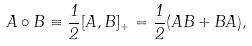<formula> <loc_0><loc_0><loc_500><loc_500>A \circ B \equiv \frac { 1 } { 2 } [ A , B ] _ { + } = \frac { 1 } { 2 } ( A B + B A ) ,</formula> 